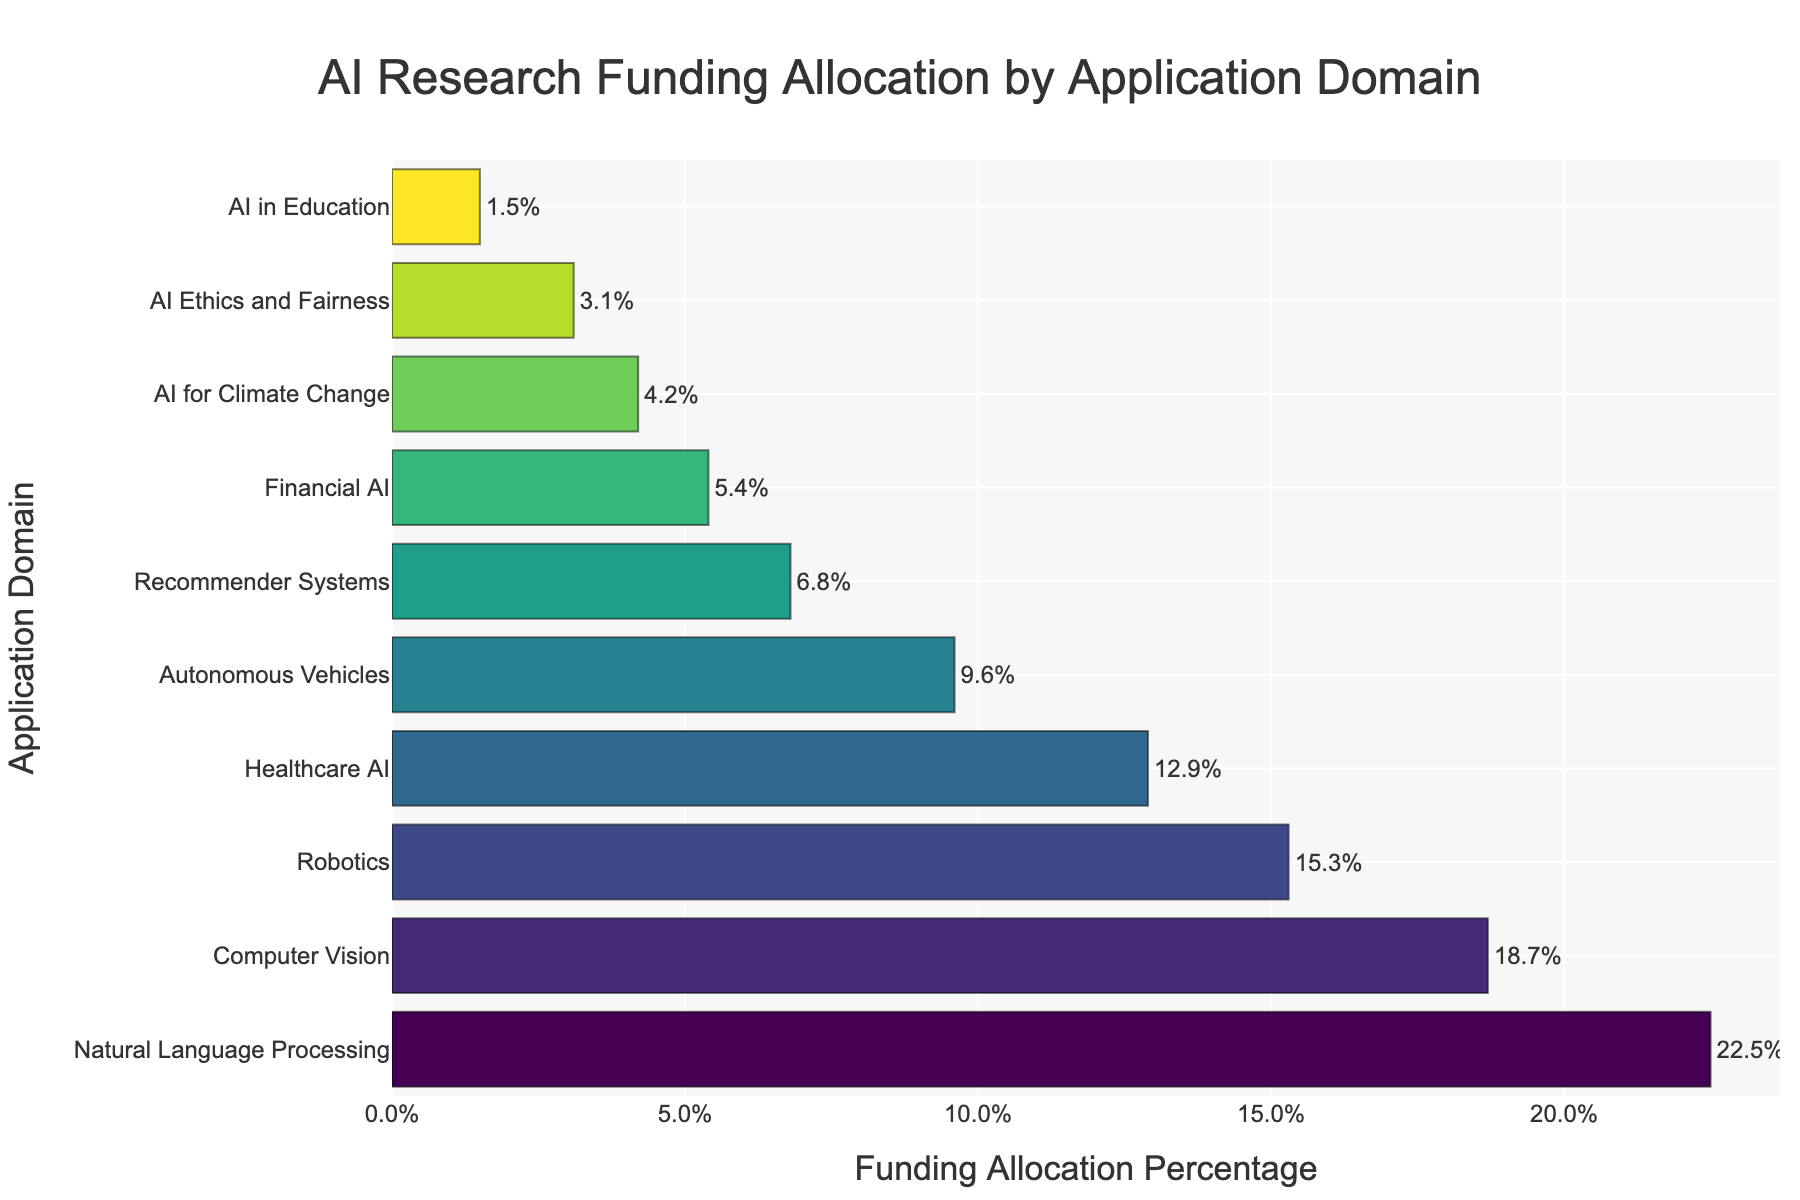What is the application domain with the highest funding allocation percentage? The bar chart shows the allocation percentages for different AI research application domains. The longest bar represents the domain with the highest percentage.
Answer: Natural Language Processing Which application domain has a funding allocation of 15.3%? By matching the percentage to the y-axis labels, we can identify which domain corresponds to 15.3%.
Answer: Robotics What is the total funding allocation for Natural Language Processing and Computer Vision? The chart shows that Natural Language Processing has 22.5% and Computer Vision has 18.7%. Summing these two percentages gives the total.
Answer: 41.2% How much higher is the funding allocation for Healthcare AI compared to AI in Education? The chart shows that Healthcare AI has 12.9% and AI in Education has 1.5%. Subtracting the two percentages yields the difference.
Answer: 11.4% What are the bottom three application domains in terms of funding allocation percentage? By looking at the shortest bars, we can identify the three domains with the lowest funding percentages.
Answer: AI Ethics and Fairness, AI for Climate Change, AI in Education Which application domains have funding allocations greater than 15% but less than 20%? Check the bars that fall within the specified range of percentages, then identify the corresponding domains on the y-axis.
Answer: Computer Vision, Robotics What is the combined funding allocation percentage for AI for Climate Change, AI Ethics and Fairness, and AI in Education? Summing the percentages of AI for Climate Change (4.2%), AI Ethics and Fairness (3.1%), and AI in Education (1.5%) gives the total.
Answer: 8.8% Which domain has the closest funding allocation percentage to 10%? Comparing all percentages shown on the bars to 10%, we find the closest match.
Answer: Autonomous Vehicles What is the color gradient pattern seen in the bars? Observing the color changes from one bar to the next, note the range of colors used and their sequence.
Answer: The bars vary in color along a Viridis scale, from dark blue to yellow-green How does the funding for Financial AI compare to Recommender Systems? Check the bar lengths for both Financial AI and Recommender Systems, then determine which is longer.
Answer: Recommender Systems have higher funding allocation 